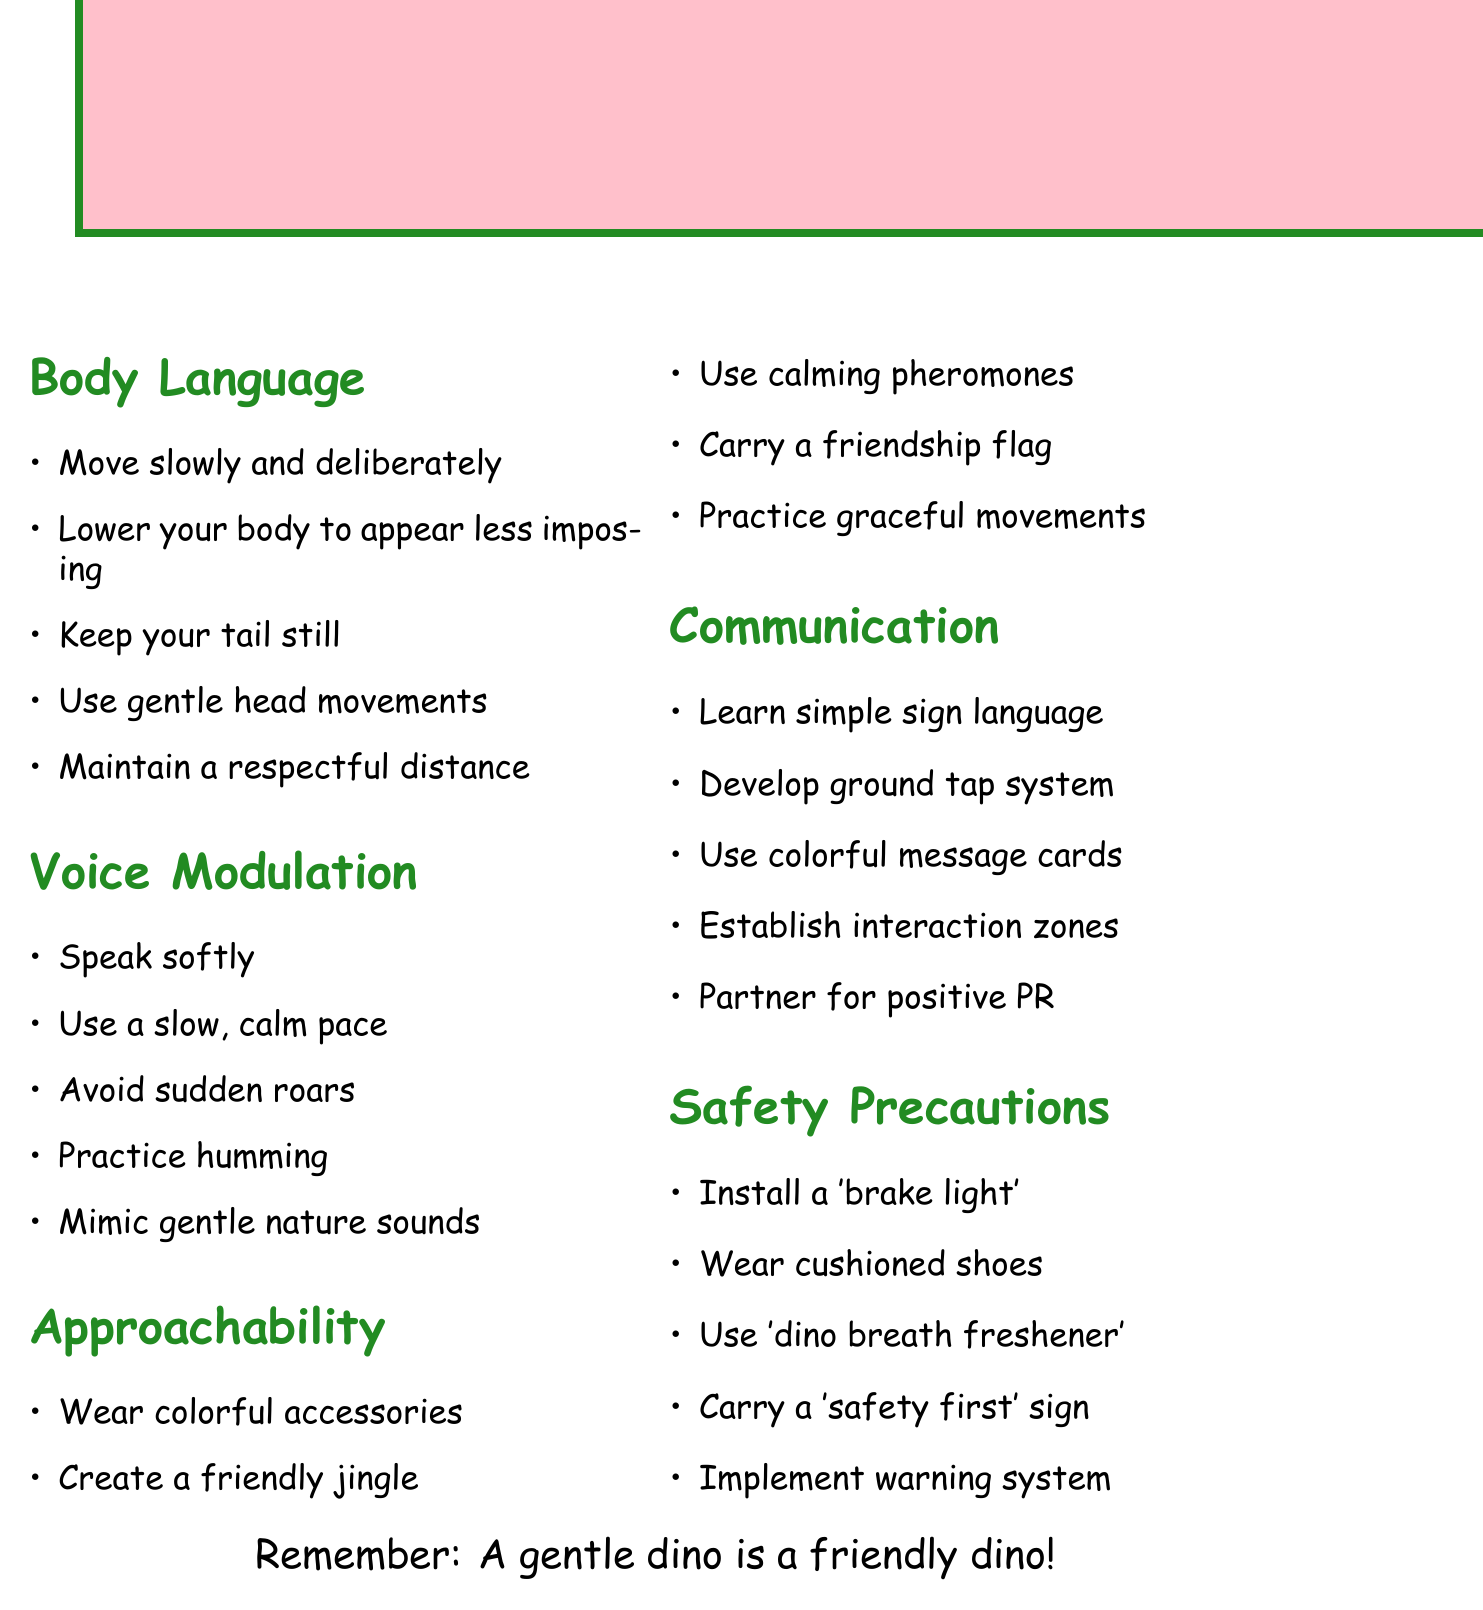what is the title of the document? The title can be found at the beginning of the memo, highlighting its main focus.
Answer: Gentle Interaction Guidelines for Empathetic Dinosaurs how many feet should a dinosaur maintain from populated areas? The memo specifies a respectful distance to ensure human comfort.
Answer: 50 feet what is one suggested voice modulation technique? This refers to specific techniques proposed in the document for effective interaction.
Answer: Speak softly what is an approachability technique mentioned? This asks for specific suggestions to enhance the dinosaur's friendly appearance.
Answer: Wear colorful accessories which safety precaution involves a visual signal? This question refers to a specific safety measure that helps communicate intentions.
Answer: Install a 'brake light' what kind of sounds should dinosaurs mimic? This prompts an answer regarding natural sounds to create a calming environment.
Answer: Gentle nature sounds how can dinosaurs communicate emotions? This question requires reasoning about the methods of communication mentioned in the document.
Answer: Ground tap system what is the purpose of carrying a friendship flag? This question explores the intention behind a specific approachability technique outlined in the memo.
Answer: Signal peaceful intentions what is recommended for practicing graceful movements? This relates to a strategy to promote better interactions through physical behavior.
Answer: Yoga or tai chi 